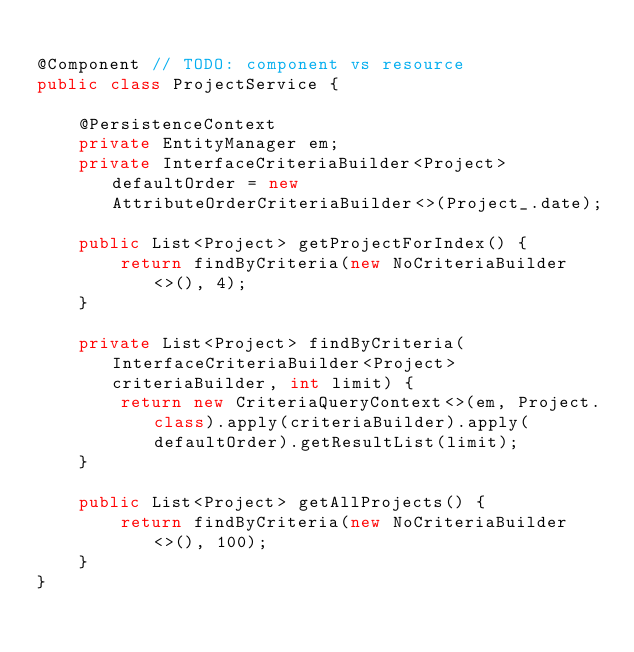Convert code to text. <code><loc_0><loc_0><loc_500><loc_500><_Java_>
@Component // TODO: component vs resource
public class ProjectService {

    @PersistenceContext
    private EntityManager em;
    private InterfaceCriteriaBuilder<Project> defaultOrder = new AttributeOrderCriteriaBuilder<>(Project_.date);

    public List<Project> getProjectForIndex() {
        return findByCriteria(new NoCriteriaBuilder<>(), 4);
    }

    private List<Project> findByCriteria(InterfaceCriteriaBuilder<Project> criteriaBuilder, int limit) {
        return new CriteriaQueryContext<>(em, Project.class).apply(criteriaBuilder).apply(defaultOrder).getResultList(limit);
    }

    public List<Project> getAllProjects() {
        return findByCriteria(new NoCriteriaBuilder<>(), 100);
    }
}
</code> 